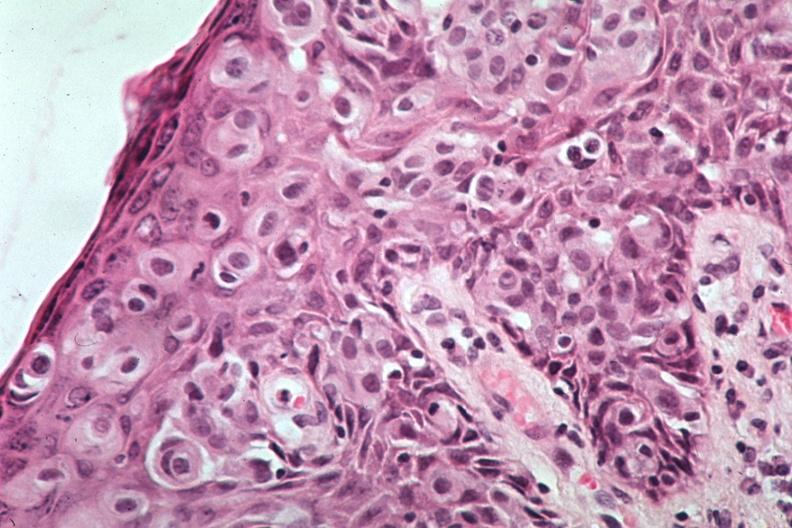s an opened peritoneal cavity cause by fibrous band strangulation a quite excellent example of pagets disease?
Answer the question using a single word or phrase. No 